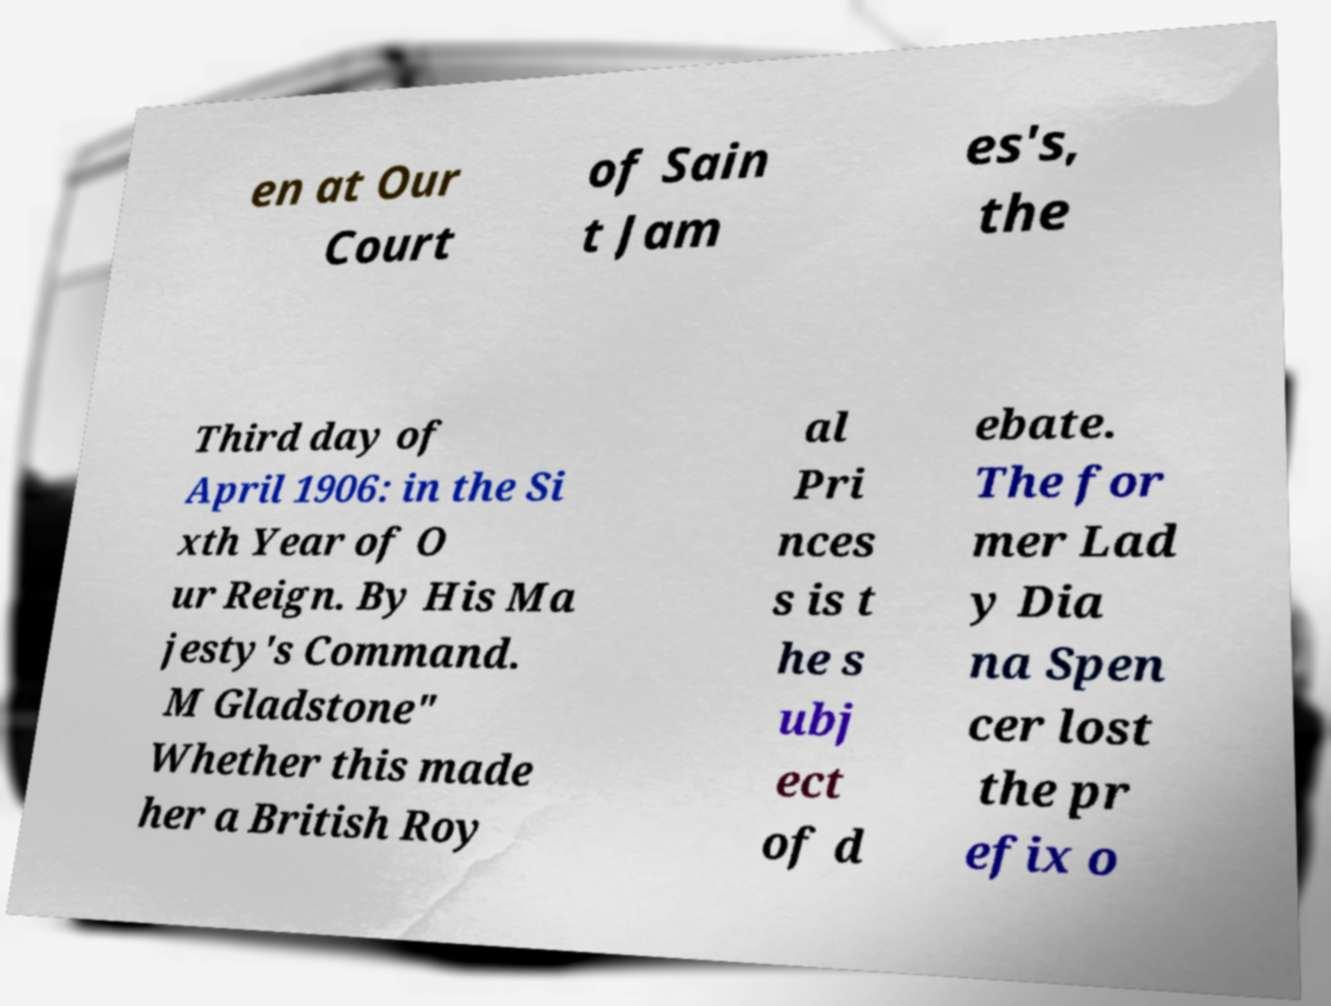Could you extract and type out the text from this image? en at Our Court of Sain t Jam es's, the Third day of April 1906: in the Si xth Year of O ur Reign. By His Ma jesty's Command. M Gladstone" Whether this made her a British Roy al Pri nces s is t he s ubj ect of d ebate. The for mer Lad y Dia na Spen cer lost the pr efix o 